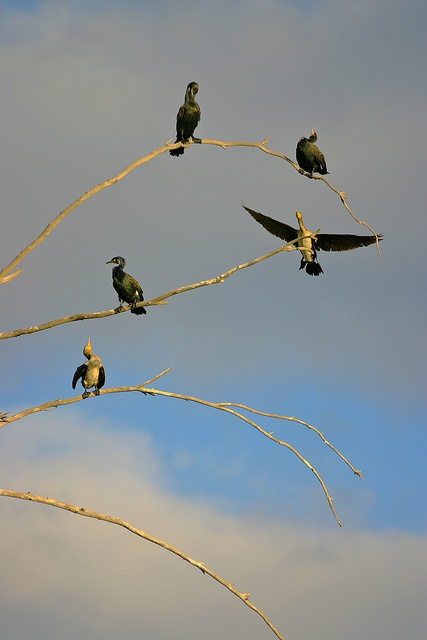Describe the objects in this image and their specific colors. I can see bird in gray, black, olive, and tan tones, bird in gray, black, darkgray, and olive tones, bird in gray, black, olive, and darkgray tones, bird in gray, black, olive, and darkgray tones, and bird in gray, black, olive, and tan tones in this image. 